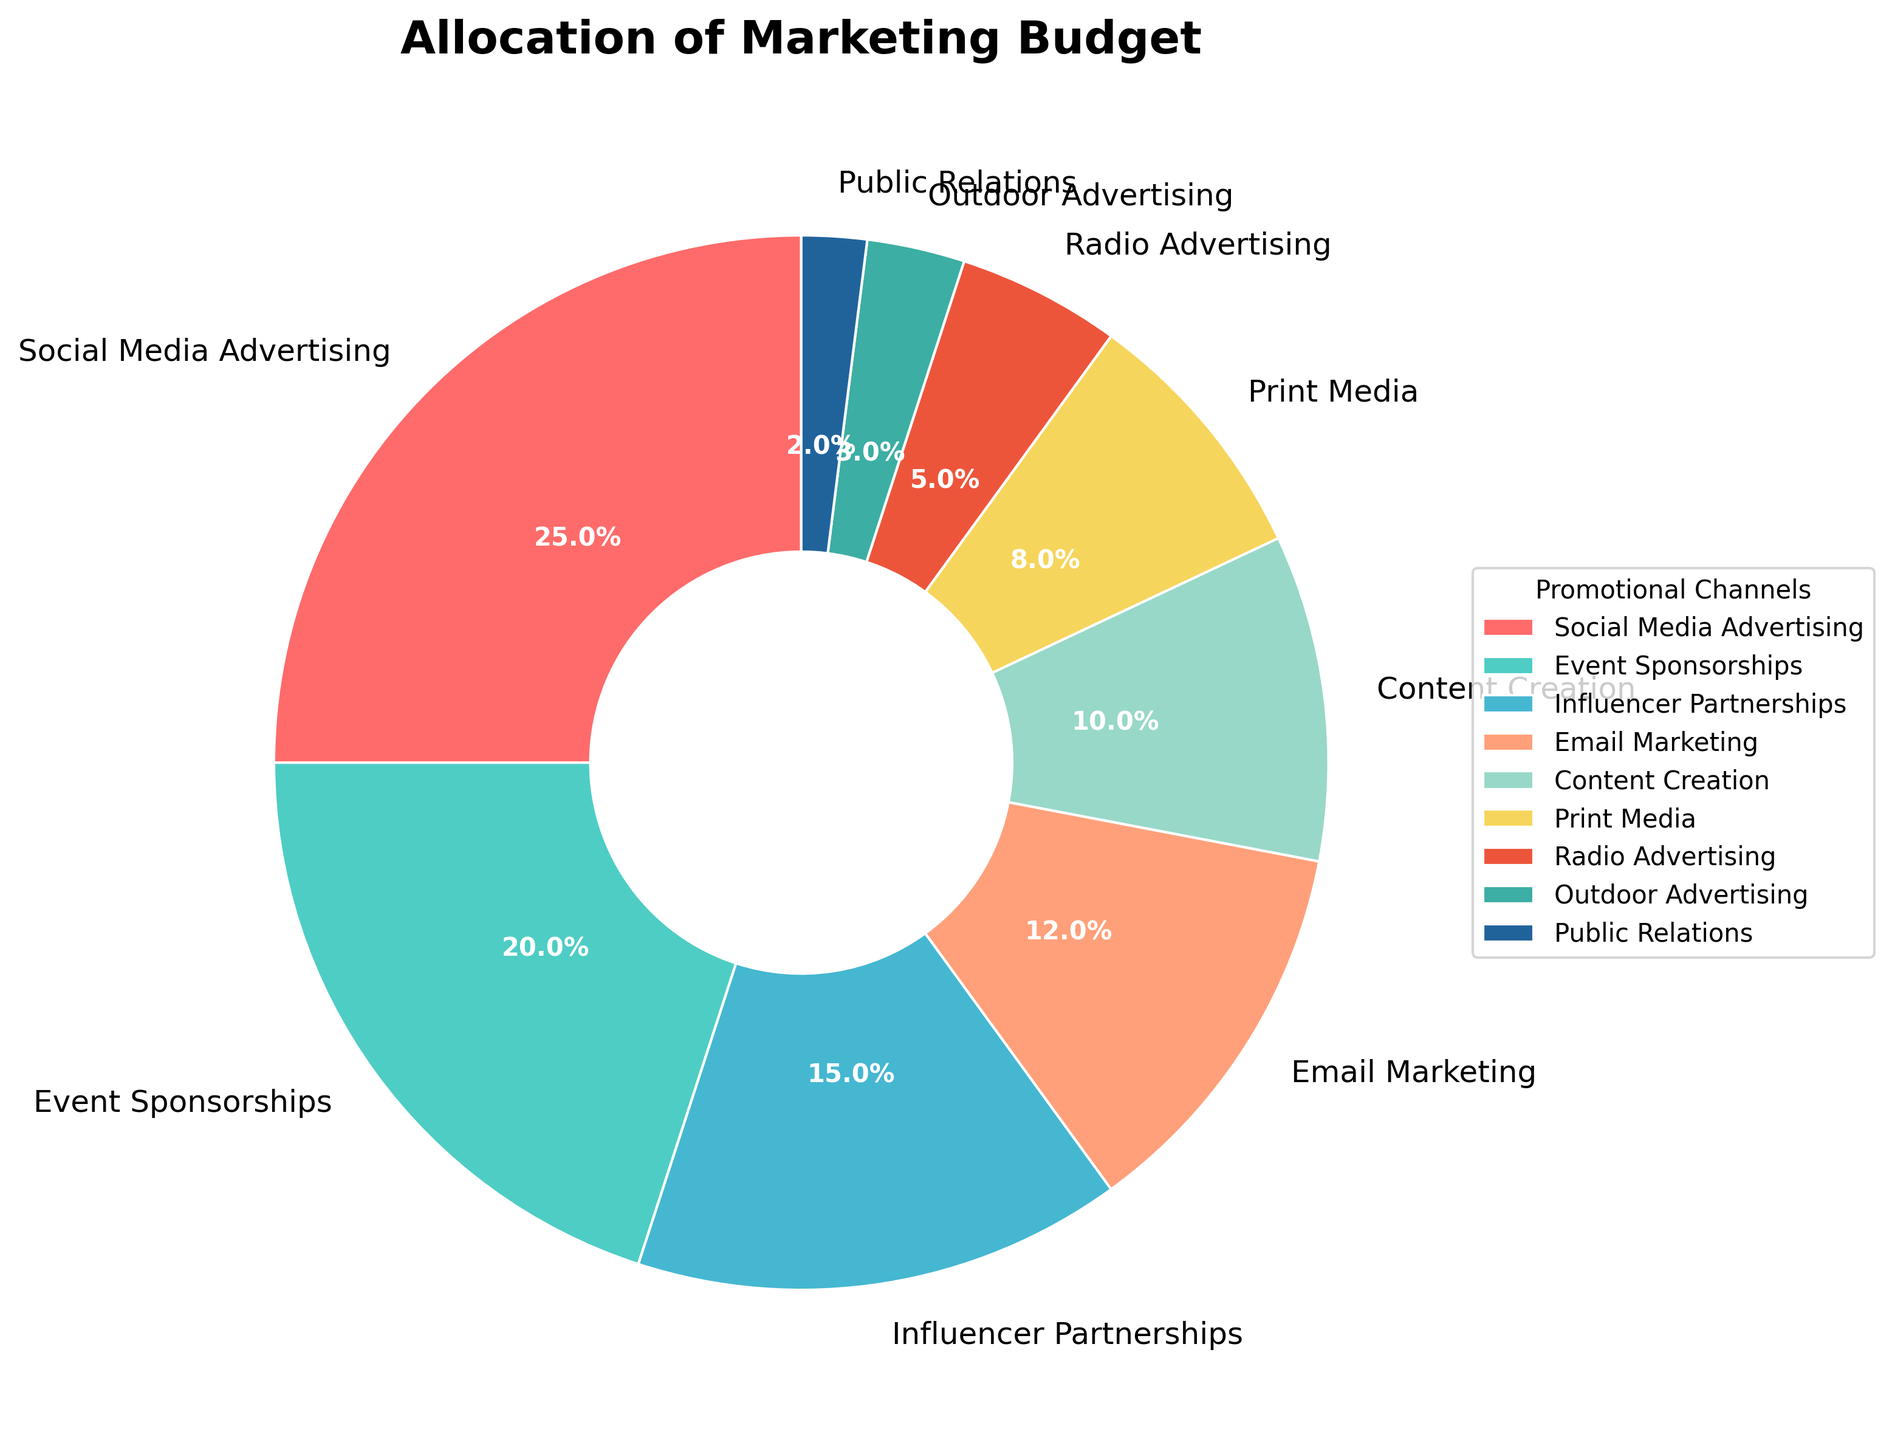Which promotional channel has the largest allocation? By observing the pie chart, the segment with the largest size corresponds to the promotional channel with the biggest allocation. In this case, it is Social Media Advertising.
Answer: Social Media Advertising What's the total percentage allocated to Print Media and Radio Advertising? Identify the segments labeled Print Media and Radio Advertising and sum their respective percentages. Print Media is 8%, and Radio Advertising is 5%. Thus, 8% + 5% = 13%.
Answer: 13% Which channel has a greater allocation, Email Marketing or Content Creation? Locate the segments for Email Marketing and Content Creation and compare their percentages. Email Marketing has 12%, while Content Creation has 10%, making Email Marketing greater.
Answer: Email Marketing What percentage of the budget is allocated to channels other than Social Media Advertising? First, note Social Media Advertising's allocation (25%). Subtract this from 100% to find the remaining allocation: 100% - 25% = 75%.
Answer: 75% If the allocations for Email Marketing and Influencer Partnerships were combined into a single channel, what would be its percentage? Add the percentages for Email Marketing (12%) and Influencer Partnerships (15%): 12% + 15% = 27%.
Answer: 27% What is the combined percentage of Event Sponsorships, Public Relations, and Outdoor Advertising? Add the percentages for Event Sponsorships (20%), Public Relations (2%), and Outdoor Advertising (3%): 20% + 2% + 3% = 25%.
Answer: 25% Which promotional channels have allocations less than 10%? Observe and list the segments with percentages below 10%. These are Print Media (8%), Radio Advertising (5%), Outdoor Advertising (3%), and Public Relations (2%).
Answer: Print Media, Radio Advertising, Outdoor Advertising, Public Relations What is the difference in budget allocation between the largest and smallest channels? Identify the largest (Social Media Advertising with 25%) and smallest (Public Relations with 2%) allocations. Subtract the smallest from the largest: 25% - 2% = 23%.
Answer: 23% 